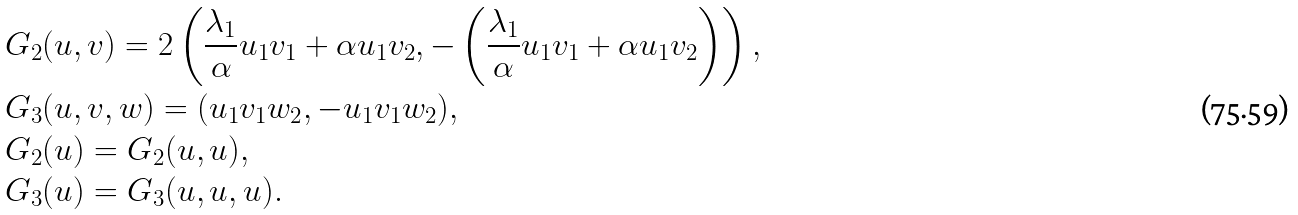<formula> <loc_0><loc_0><loc_500><loc_500>& G _ { 2 } ( u , v ) = 2 \left ( \frac { \lambda _ { 1 } } { \alpha } u _ { 1 } v _ { 1 } + \alpha u _ { 1 } v _ { 2 } , - \left ( \frac { \lambda _ { 1 } } { \alpha } u _ { 1 } v _ { 1 } + \alpha u _ { 1 } v _ { 2 } \right ) \right ) , \\ & G _ { 3 } ( u , v , w ) = ( u _ { 1 } v _ { 1 } w _ { 2 } , - u _ { 1 } v _ { 1 } w _ { 2 } ) , \\ & G _ { 2 } ( u ) = G _ { 2 } ( u , u ) , \\ & G _ { 3 } ( u ) = G _ { 3 } ( u , u , u ) .</formula> 